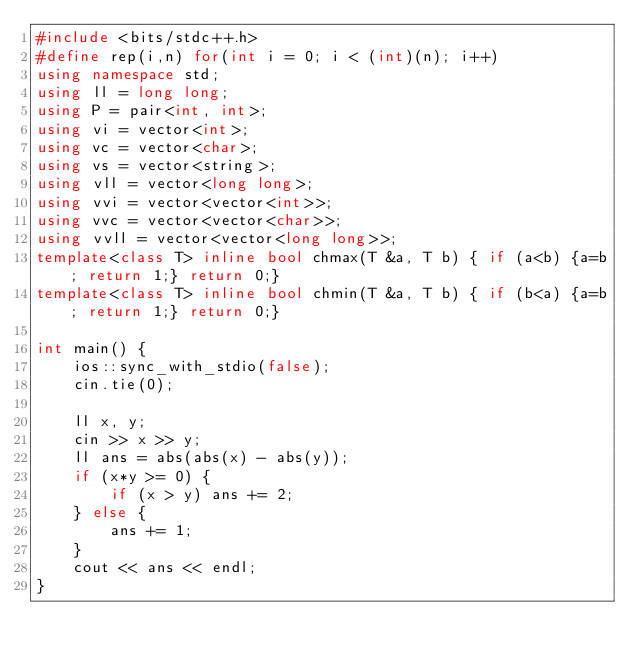<code> <loc_0><loc_0><loc_500><loc_500><_C++_>#include <bits/stdc++.h>
#define rep(i,n) for(int i = 0; i < (int)(n); i++)
using namespace std;
using ll = long long;
using P = pair<int, int>;
using vi = vector<int>;
using vc = vector<char>;
using vs = vector<string>;
using vll = vector<long long>;
using vvi = vector<vector<int>>;
using vvc = vector<vector<char>>;
using vvll = vector<vector<long long>>;
template<class T> inline bool chmax(T &a, T b) { if (a<b) {a=b; return 1;} return 0;}
template<class T> inline bool chmin(T &a, T b) { if (b<a) {a=b; return 1;} return 0;}

int main() {
    ios::sync_with_stdio(false);
    cin.tie(0);
    
    ll x, y;
    cin >> x >> y;
    ll ans = abs(abs(x) - abs(y));
    if (x*y >= 0) {
        if (x > y) ans += 2;
    } else {
        ans += 1;
    }
    cout << ans << endl;
}</code> 